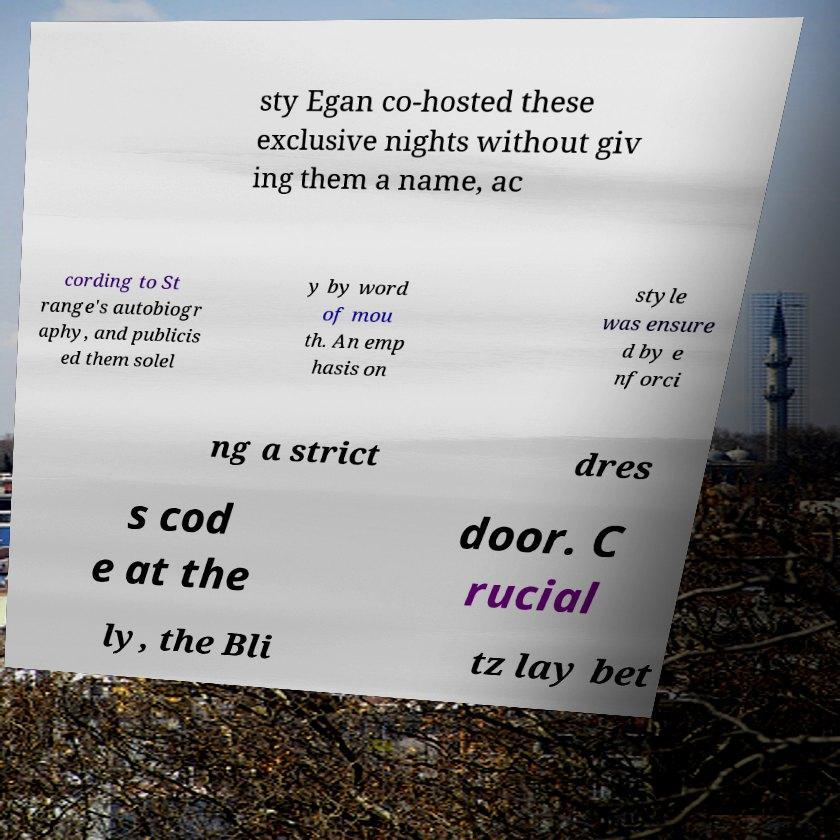What messages or text are displayed in this image? I need them in a readable, typed format. sty Egan co-hosted these exclusive nights without giv ing them a name, ac cording to St range's autobiogr aphy, and publicis ed them solel y by word of mou th. An emp hasis on style was ensure d by e nforci ng a strict dres s cod e at the door. C rucial ly, the Bli tz lay bet 